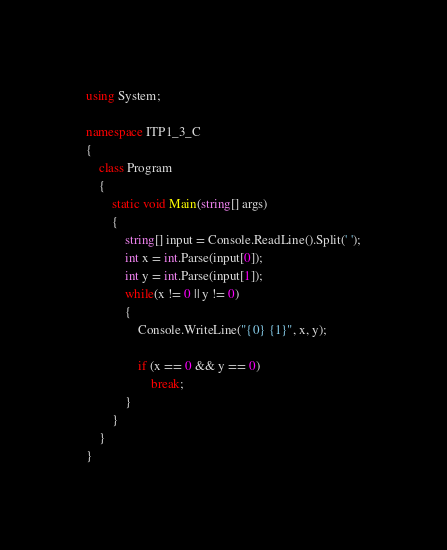<code> <loc_0><loc_0><loc_500><loc_500><_C#_>using System;

namespace ITP1_3_C
{
    class Program
    {
        static void Main(string[] args)
        {
            string[] input = Console.ReadLine().Split(' ');
            int x = int.Parse(input[0]);
            int y = int.Parse(input[1]);
            while(x != 0 || y != 0)
            {
                Console.WriteLine("{0} {1}", x, y);

                if (x == 0 && y == 0)
                    break;
            }
        }
    }
}

</code> 